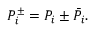Convert formula to latex. <formula><loc_0><loc_0><loc_500><loc_500>P _ { i } ^ { \pm } = P _ { i } \pm \bar { P } _ { i } .</formula> 